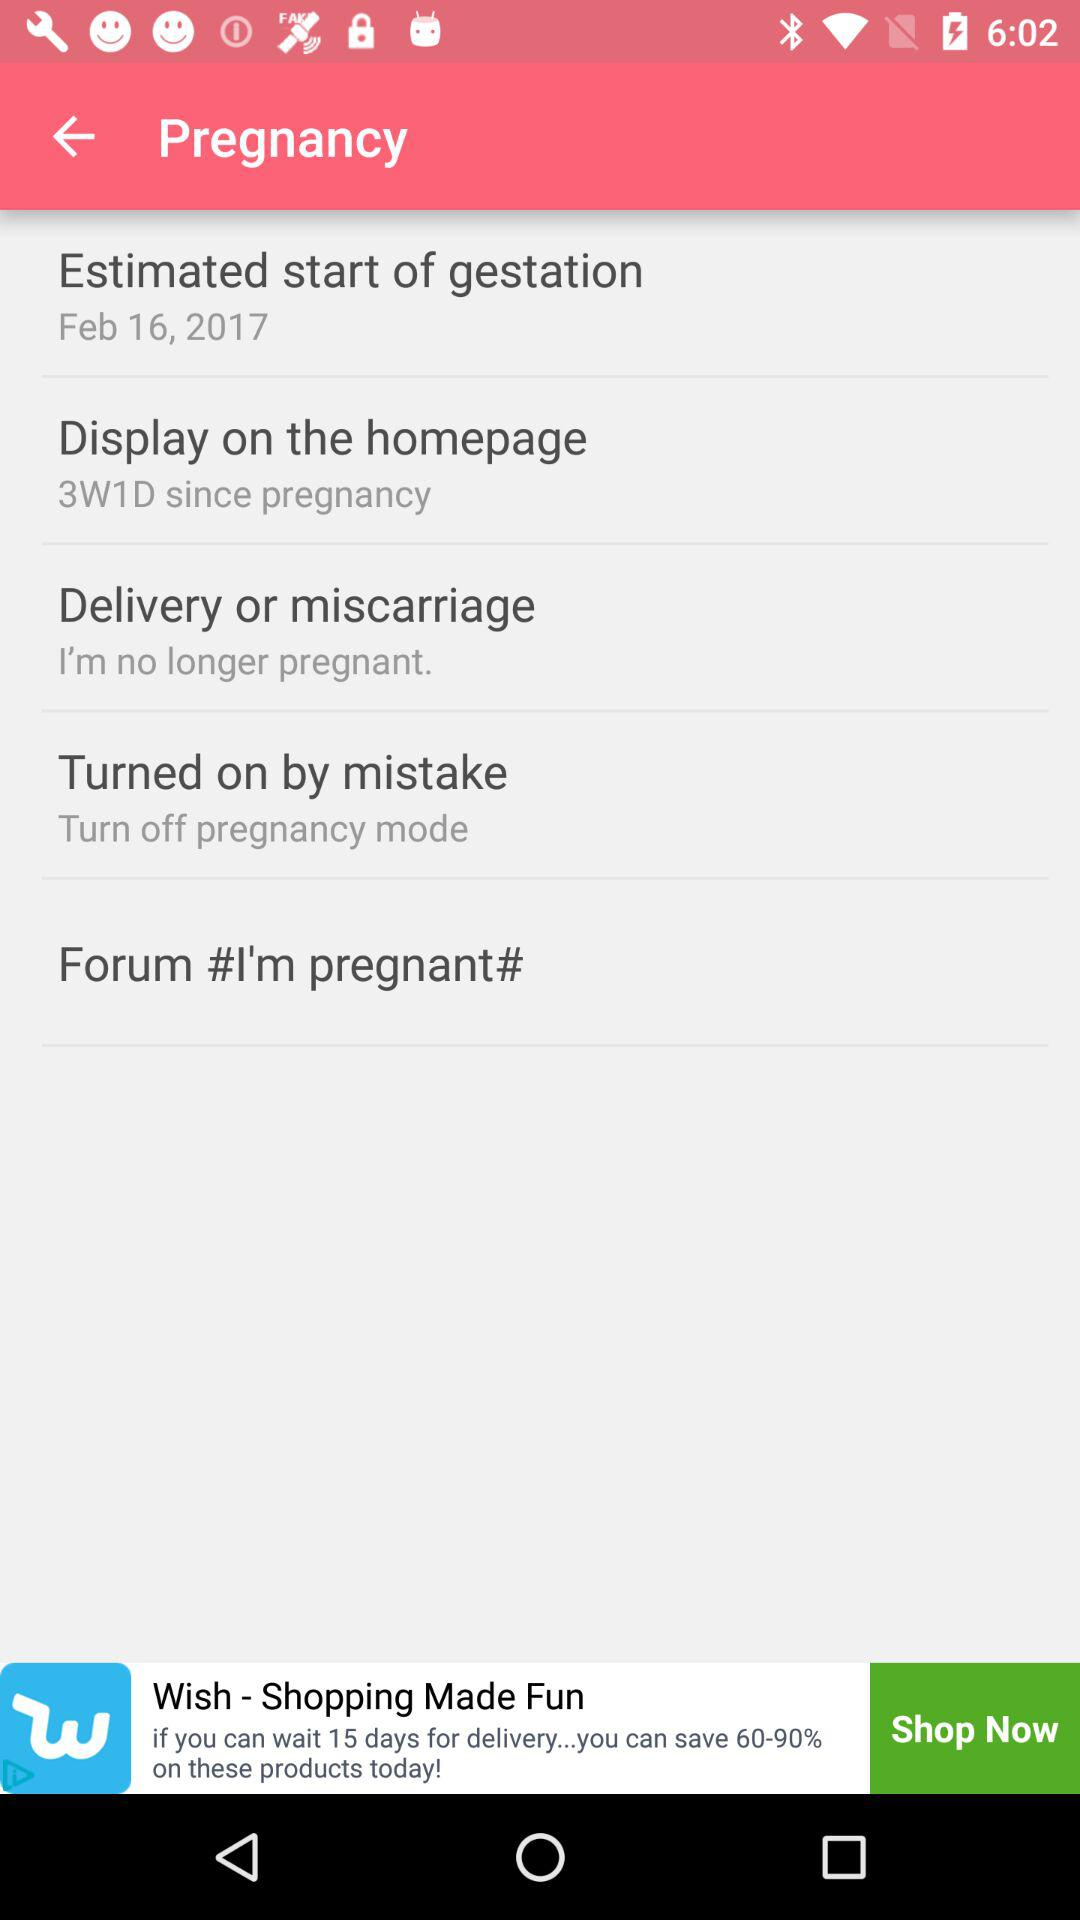How many days has it been since the start of gestation?
Answer the question using a single word or phrase. 3W1D 